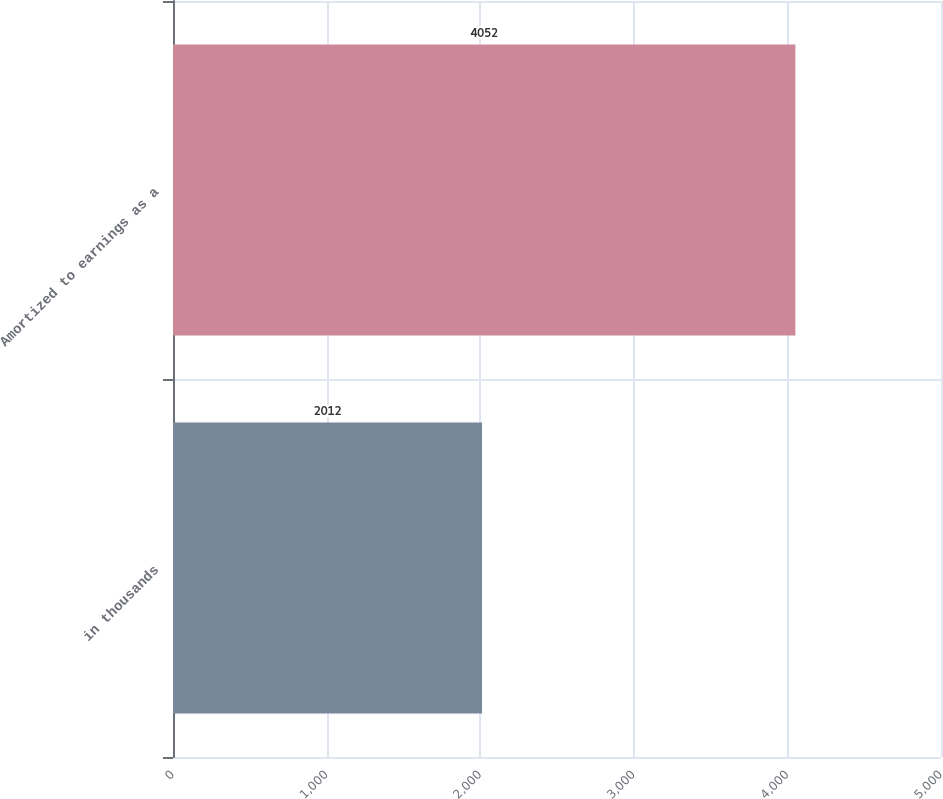Convert chart to OTSL. <chart><loc_0><loc_0><loc_500><loc_500><bar_chart><fcel>in thousands<fcel>Amortized to earnings as a<nl><fcel>2012<fcel>4052<nl></chart> 